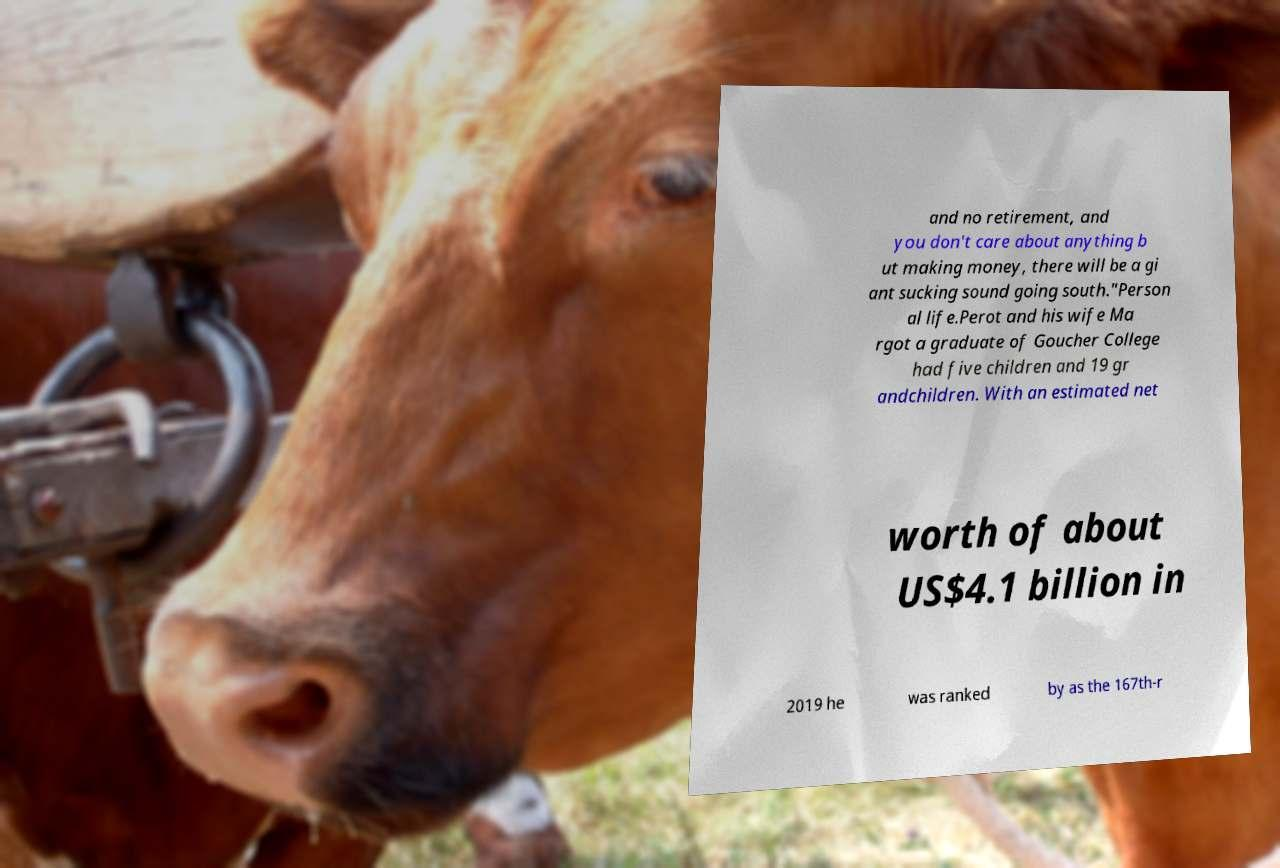There's text embedded in this image that I need extracted. Can you transcribe it verbatim? and no retirement, and you don't care about anything b ut making money, there will be a gi ant sucking sound going south."Person al life.Perot and his wife Ma rgot a graduate of Goucher College had five children and 19 gr andchildren. With an estimated net worth of about US$4.1 billion in 2019 he was ranked by as the 167th-r 